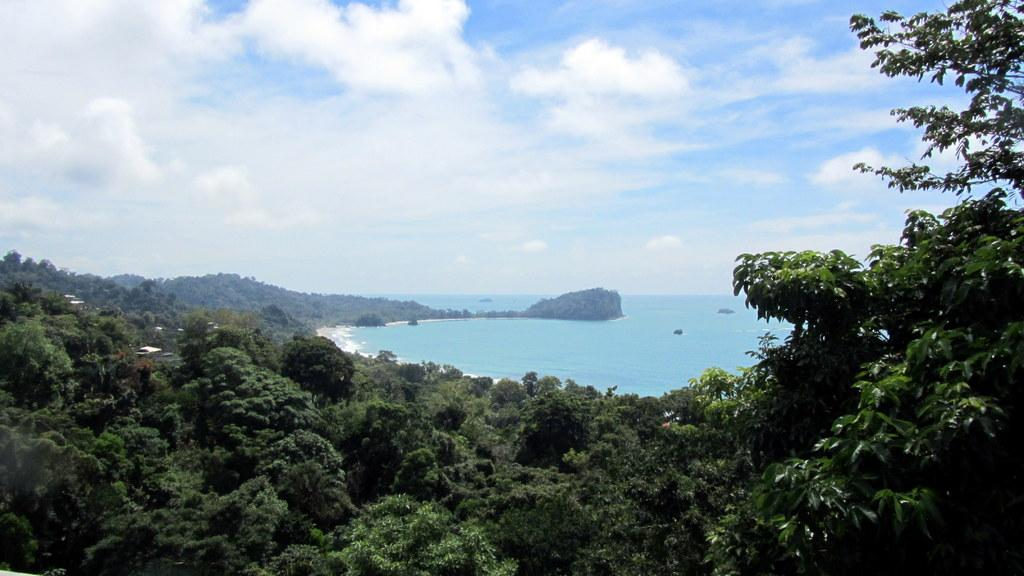What type of vegetation is present at the bottom of the image? There are many trees at the bottom of the image. What can be seen behind the trees in the image? There is water visible behind the trees. What is visible at the top of the image? The sky is visible at the top of the image. How many oranges are being balanced on the trees in the image? There are no oranges present in the image, and the trees do not appear to be balancing anything. What type of conversation is taking place between the trees in the image? There is no conversation taking place between the trees in the image, as trees do not have the ability to talk. 